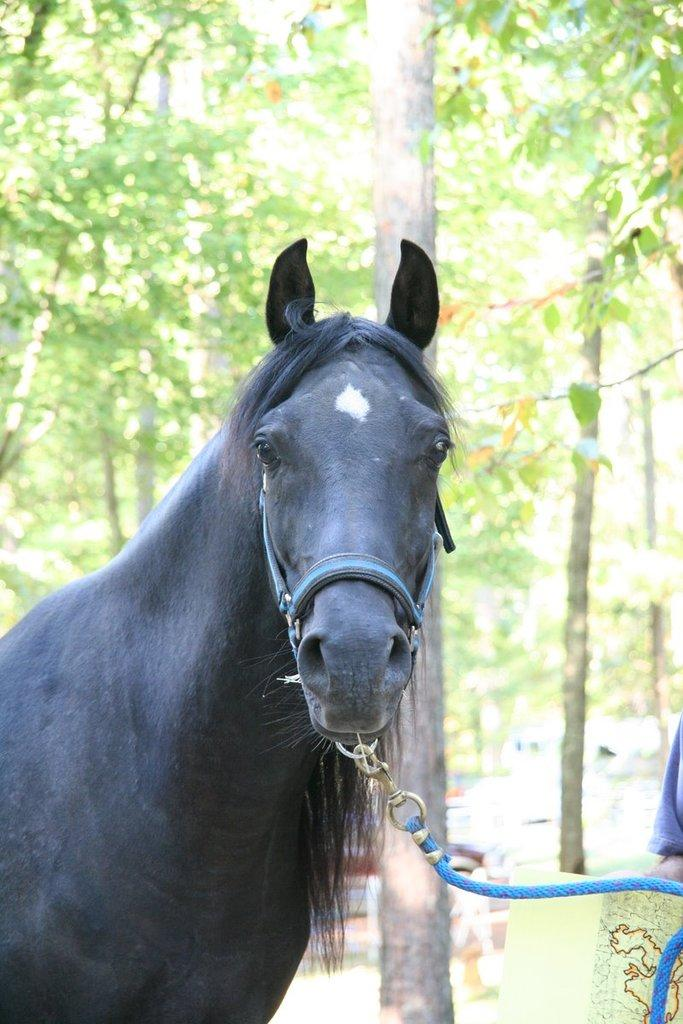What type of animal is in the image? There is a black horse in the image. What object can be seen near the horse? There is a blue rope in the image. What can be seen in the distance behind the horse and rope? Trees are visible in the background of the image. What type of stove is being used by the father in the image? There is no stove or father present in the image; it features a black horse and a blue rope. 